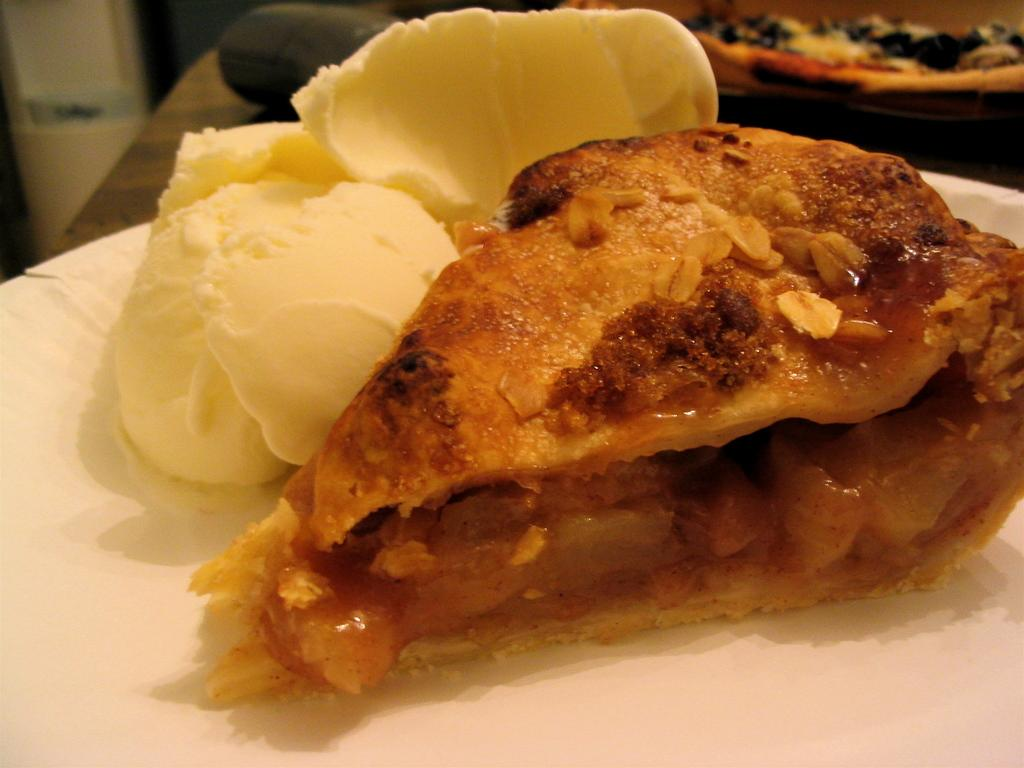What is on the plate that is visible in the image? There is food on a plate in the image. Where is the plate with food located? The plate with food is on a table. Are there any other plates with food in the image? Yes, there is another plate with food in the top right corner of the image. Can you see any grass growing on the plate with food? No, there is no grass growing on the plate with food in the image. 